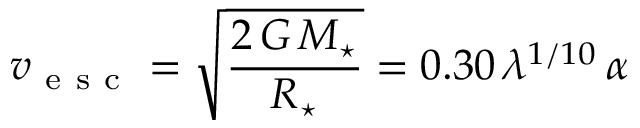Convert formula to latex. <formula><loc_0><loc_0><loc_500><loc_500>v _ { e s c } = \sqrt { \frac { 2 \, G \, M _ { ^ { * } } } { R _ { ^ { * } } } } = 0 . 3 0 \, \lambda ^ { 1 / 1 0 } \, \alpha</formula> 